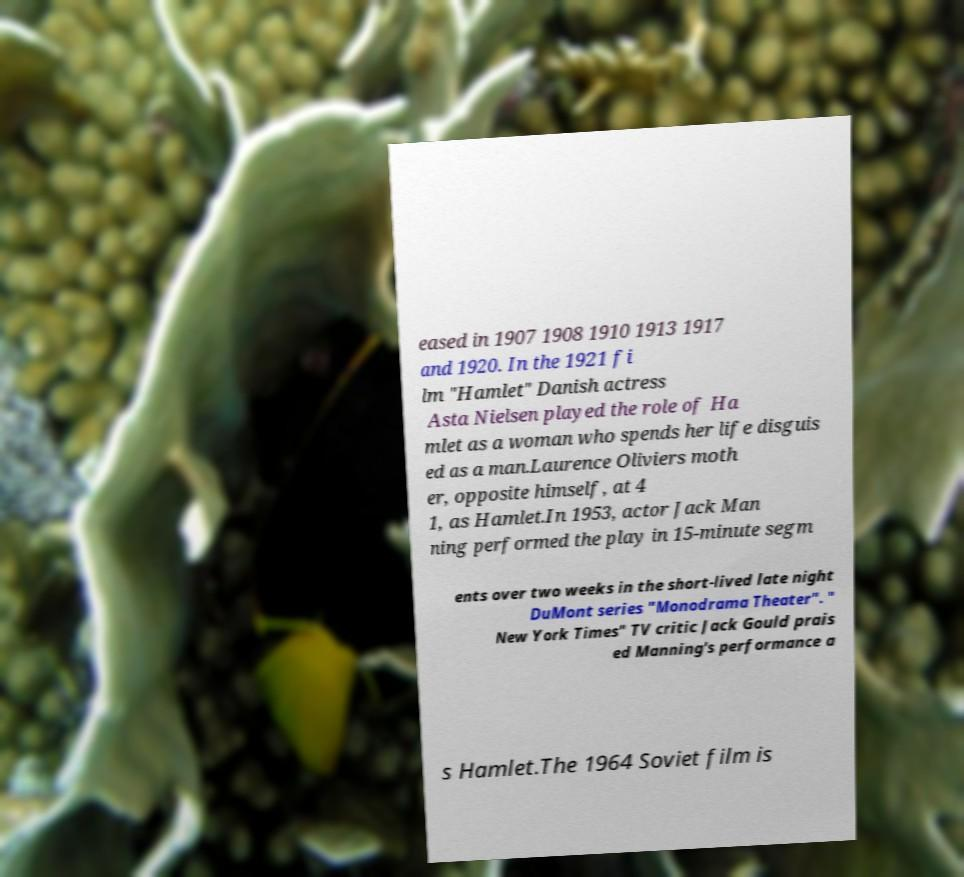I need the written content from this picture converted into text. Can you do that? eased in 1907 1908 1910 1913 1917 and 1920. In the 1921 fi lm "Hamlet" Danish actress Asta Nielsen played the role of Ha mlet as a woman who spends her life disguis ed as a man.Laurence Oliviers moth er, opposite himself, at 4 1, as Hamlet.In 1953, actor Jack Man ning performed the play in 15-minute segm ents over two weeks in the short-lived late night DuMont series "Monodrama Theater". " New York Times" TV critic Jack Gould prais ed Manning's performance a s Hamlet.The 1964 Soviet film is 